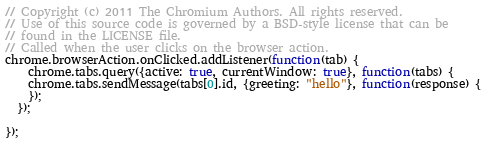Convert code to text. <code><loc_0><loc_0><loc_500><loc_500><_JavaScript_>// Copyright (c) 2011 The Chromium Authors. All rights reserved.
// Use of this source code is governed by a BSD-style license that can be
// found in the LICENSE file.
// Called when the user clicks on the browser action.
chrome.browserAction.onClicked.addListener(function(tab) {
    chrome.tabs.query({active: true, currentWindow: true}, function(tabs) {
    chrome.tabs.sendMessage(tabs[0].id, {greeting: "hello"}, function(response) {
    });
  });

});
</code> 